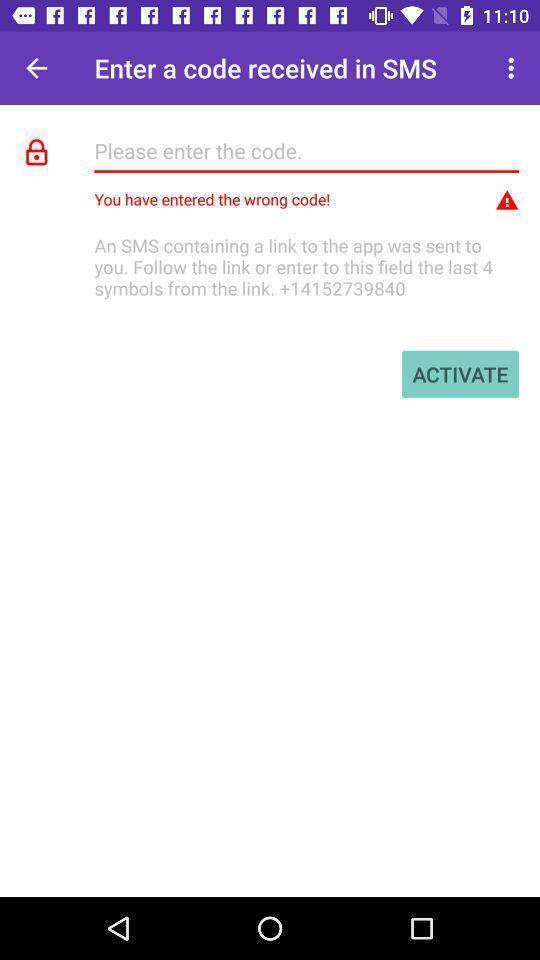What can you discern from this picture? Page showing matches of couple app. 